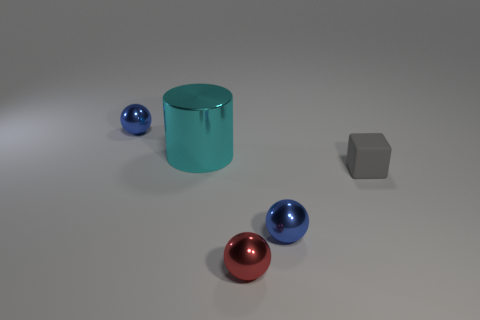Is there any other thing that has the same material as the cube?
Offer a terse response. No. Does the big metal cylinder have the same color as the tiny rubber block?
Make the answer very short. No. What number of objects are red spheres or things behind the gray thing?
Keep it short and to the point. 3. Is there a gray cube of the same size as the red metal thing?
Offer a terse response. Yes. Is the large cyan thing made of the same material as the gray object?
Make the answer very short. No. What number of things are either big cyan metal cylinders or red shiny spheres?
Keep it short and to the point. 2. What size is the cyan cylinder?
Your response must be concise. Large. Are there fewer small blocks than blue cylinders?
Your answer should be compact. No. There is a tiny blue shiny object that is in front of the tiny gray thing; what is its shape?
Your response must be concise. Sphere. There is a blue thing that is behind the matte cube; is there a small blue object that is right of it?
Provide a short and direct response. Yes. 